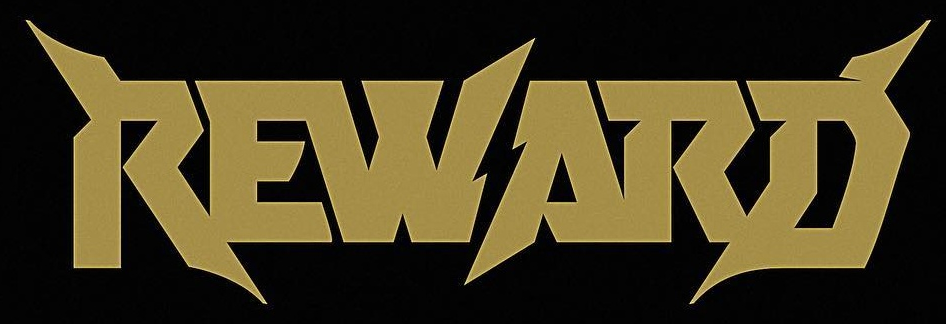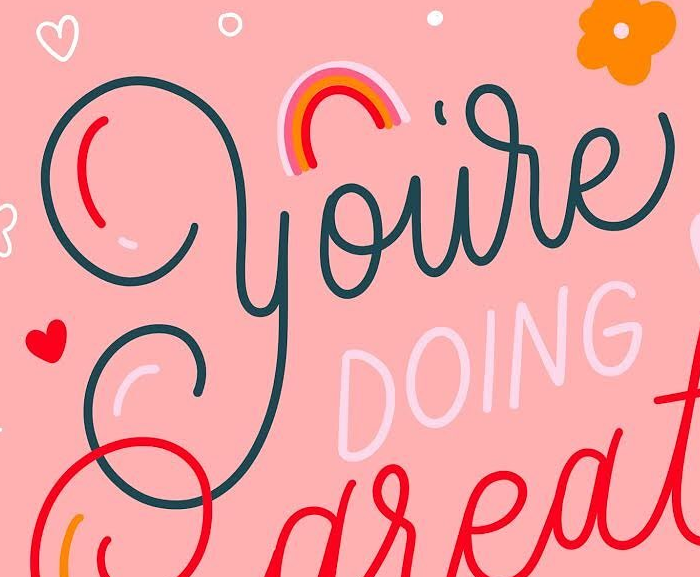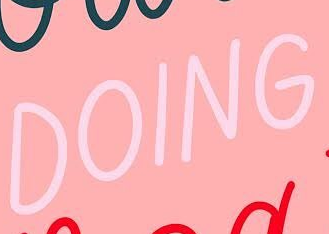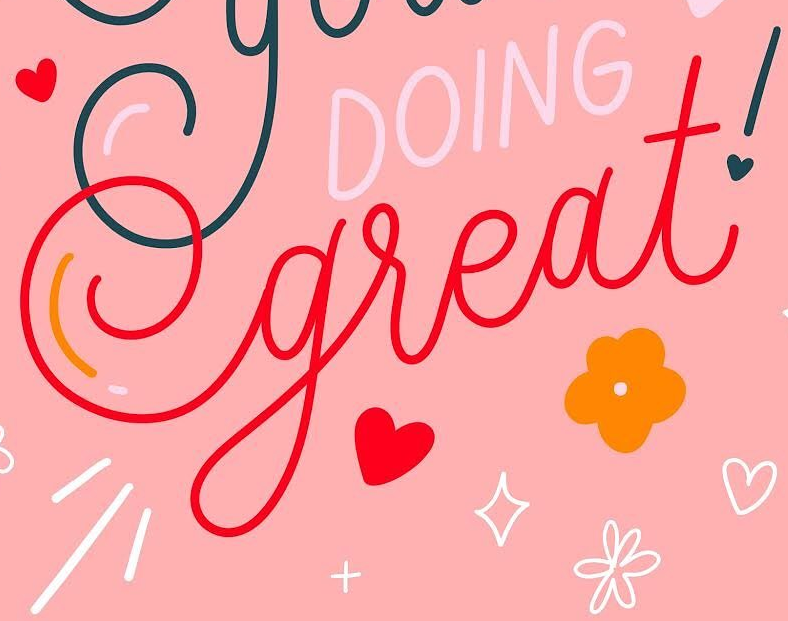Read the text from these images in sequence, separated by a semicolon. REWARD; you're; DOING; great! 